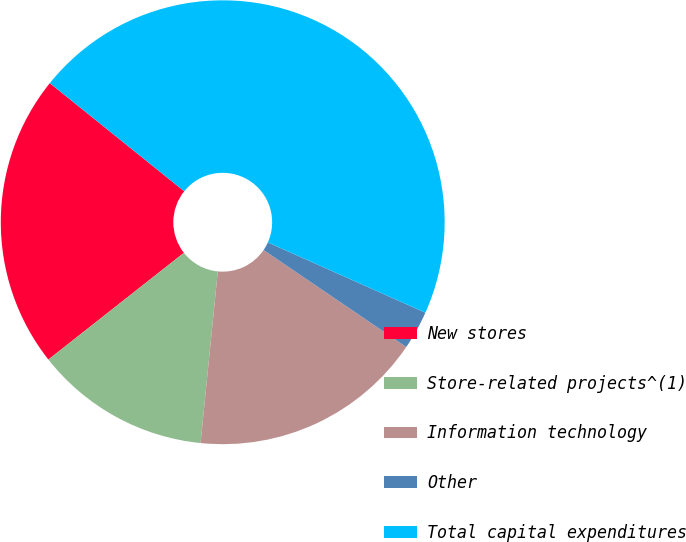Convert chart. <chart><loc_0><loc_0><loc_500><loc_500><pie_chart><fcel>New stores<fcel>Store-related projects^(1)<fcel>Information technology<fcel>Other<fcel>Total capital expenditures<nl><fcel>21.4%<fcel>12.79%<fcel>17.09%<fcel>2.82%<fcel>45.9%<nl></chart> 